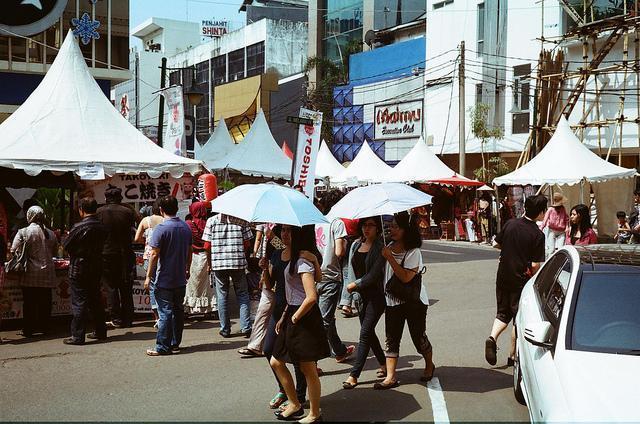Why are the people carrying umbrellas?
Answer the question by selecting the correct answer among the 4 following choices.
Options: Blocking rain, blocking sun, to dance, to sell. Blocking sun. 